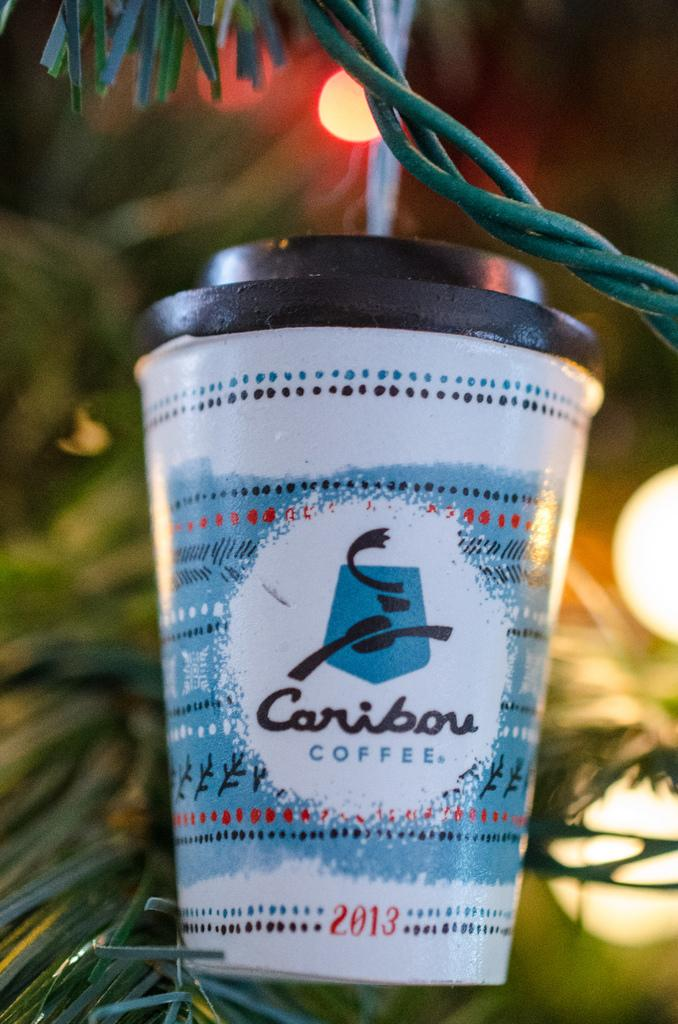Provide a one-sentence caption for the provided image. A 2013 caribou coffee ornament hangs on the tree. 